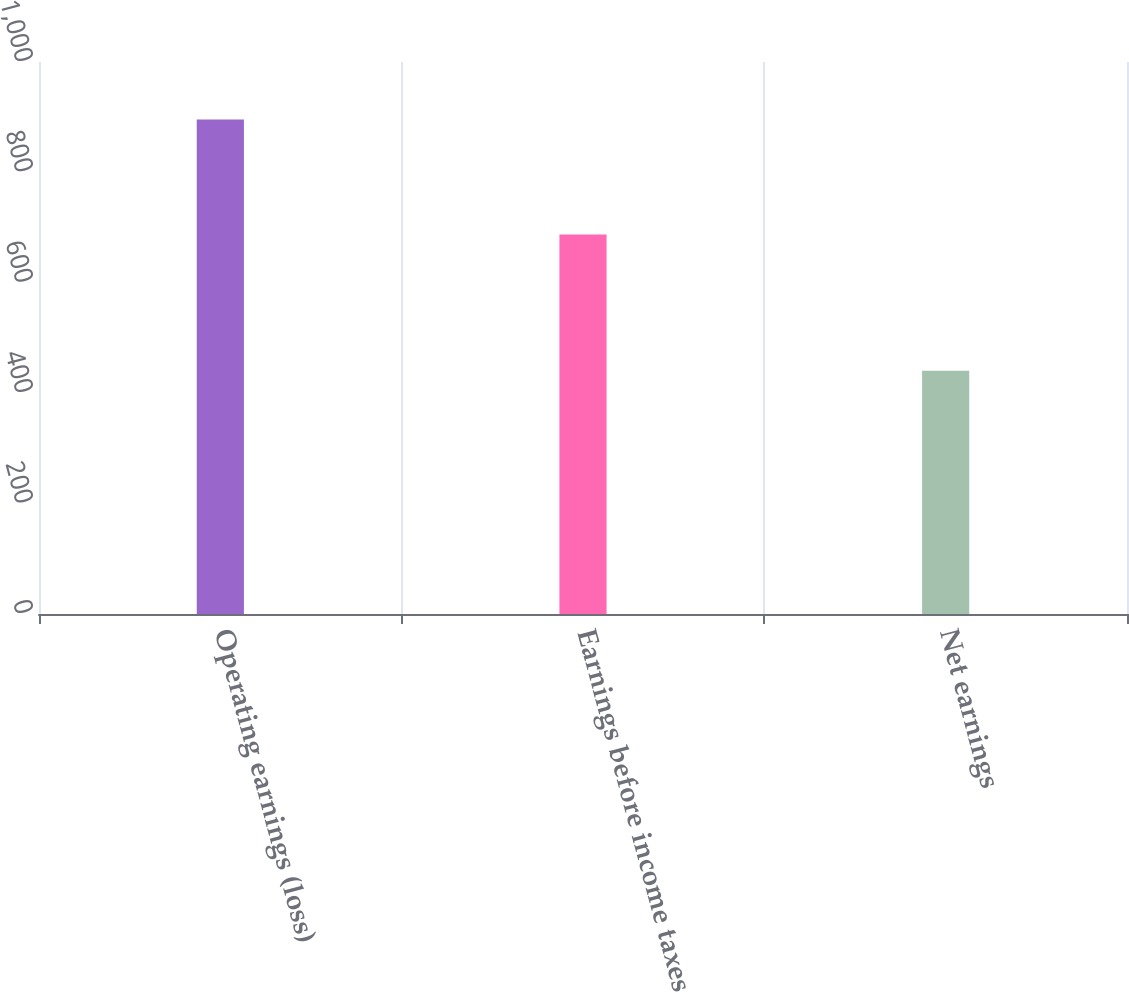<chart> <loc_0><loc_0><loc_500><loc_500><bar_chart><fcel>Operating earnings (loss)<fcel>Earnings before income taxes<fcel>Net earnings<nl><fcel>895.7<fcel>687.7<fcel>440.7<nl></chart> 